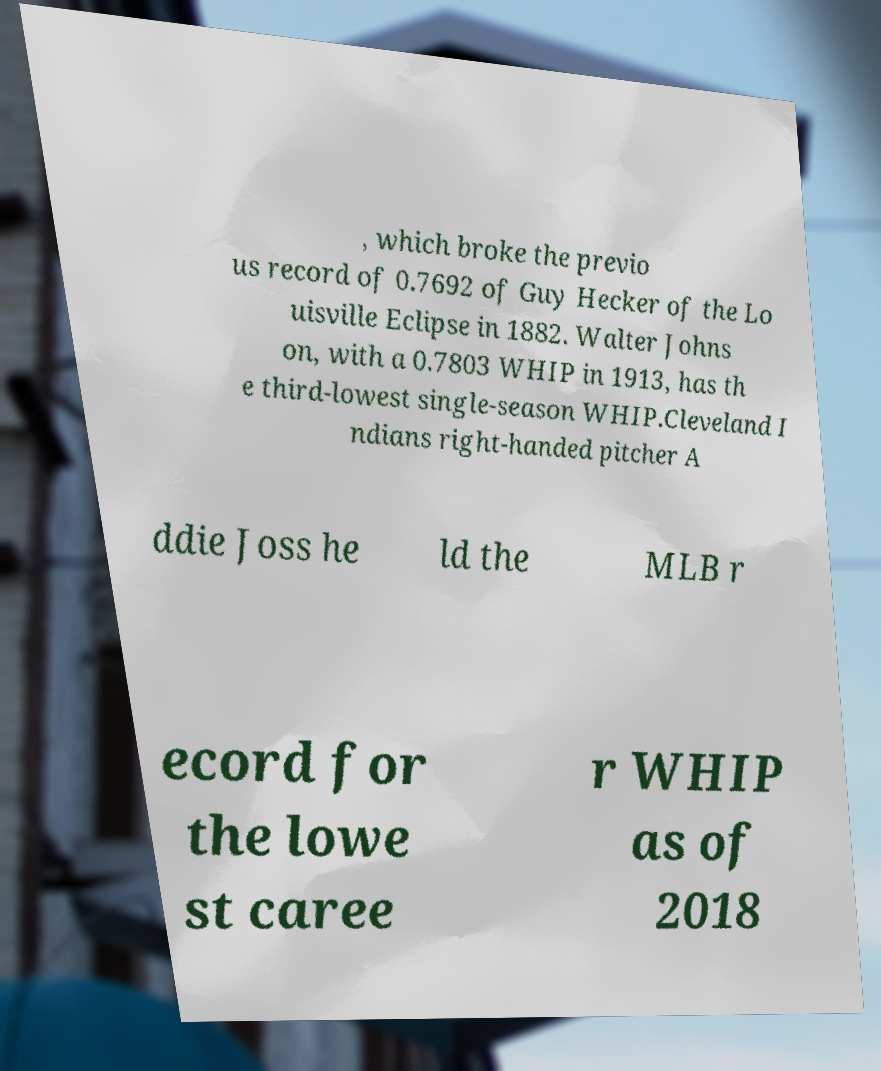For documentation purposes, I need the text within this image transcribed. Could you provide that? , which broke the previo us record of 0.7692 of Guy Hecker of the Lo uisville Eclipse in 1882. Walter Johns on, with a 0.7803 WHIP in 1913, has th e third-lowest single-season WHIP.Cleveland I ndians right-handed pitcher A ddie Joss he ld the MLB r ecord for the lowe st caree r WHIP as of 2018 